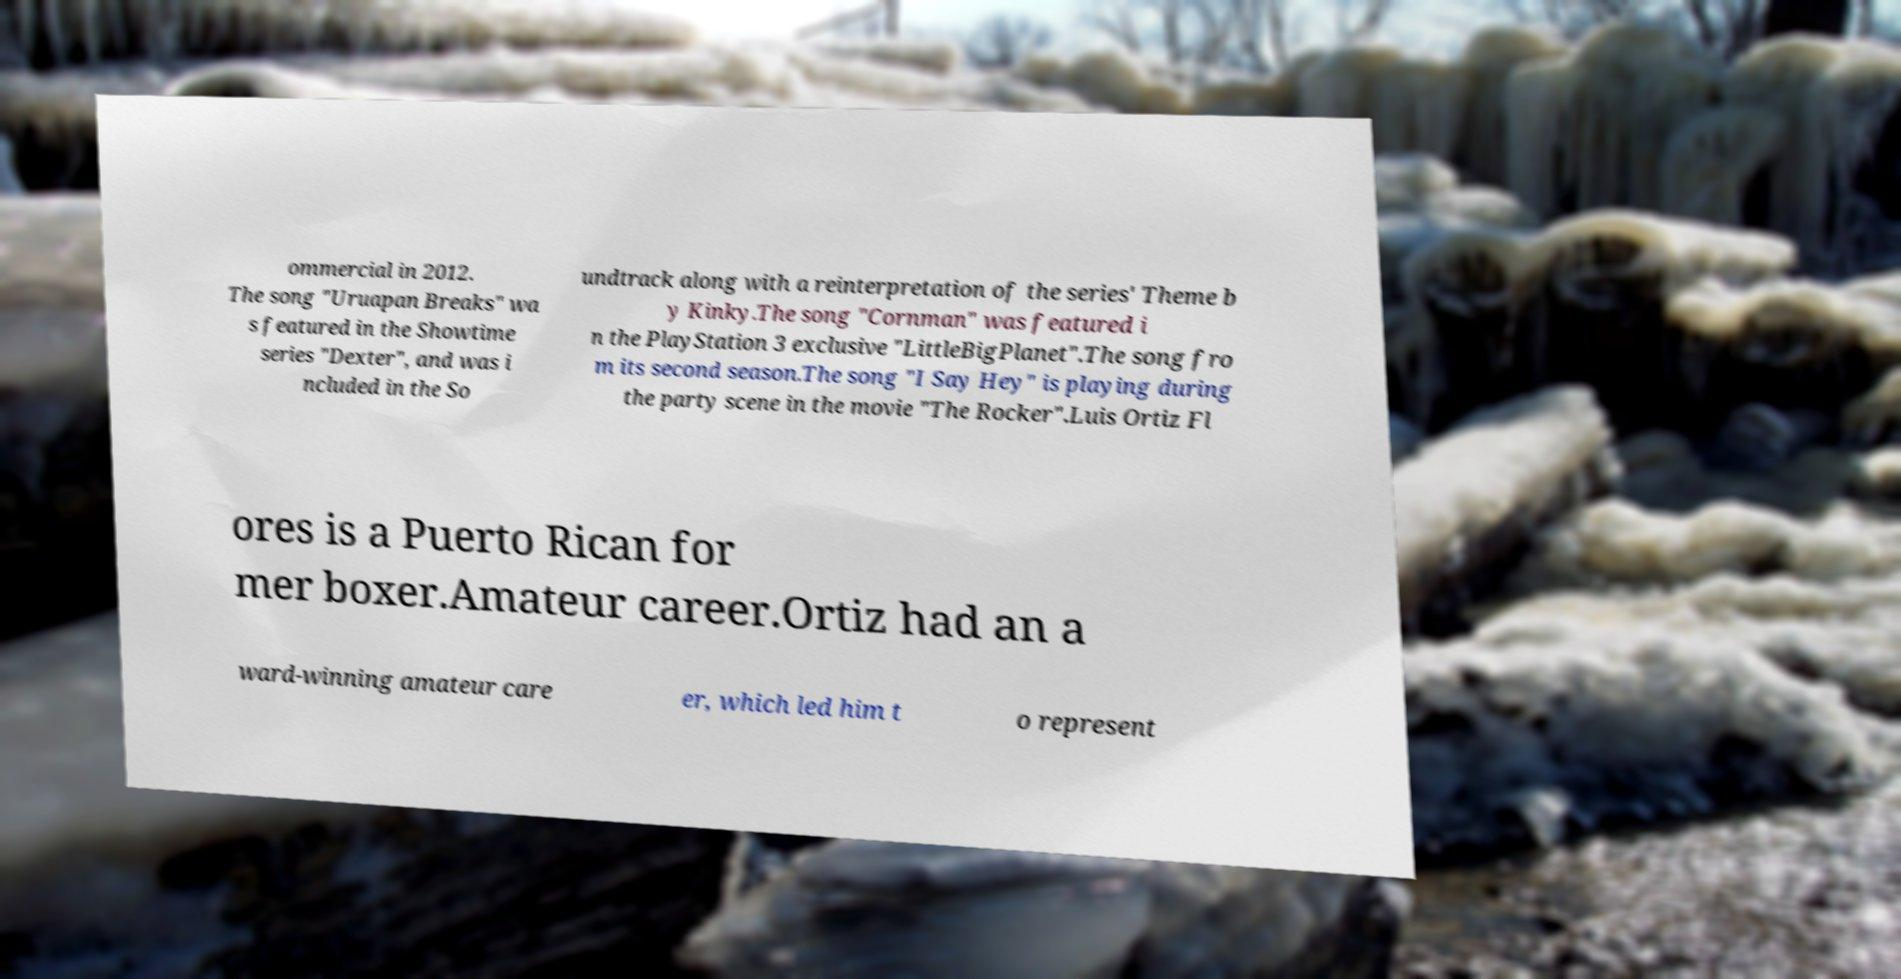Can you read and provide the text displayed in the image?This photo seems to have some interesting text. Can you extract and type it out for me? ommercial in 2012. The song "Uruapan Breaks" wa s featured in the Showtime series "Dexter", and was i ncluded in the So undtrack along with a reinterpretation of the series' Theme b y Kinky.The song "Cornman" was featured i n the PlayStation 3 exclusive "LittleBigPlanet".The song fro m its second season.The song "I Say Hey" is playing during the party scene in the movie "The Rocker".Luis Ortiz Fl ores is a Puerto Rican for mer boxer.Amateur career.Ortiz had an a ward-winning amateur care er, which led him t o represent 